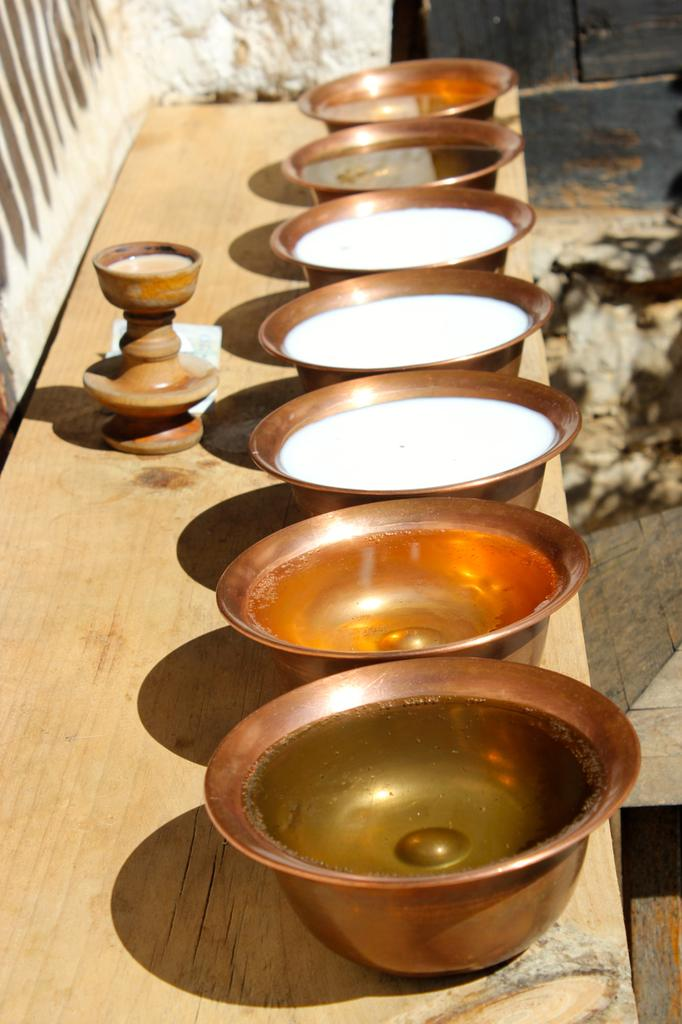What objects are present in the image? There are bowls in the image. What is inside the bowls? The bowls contain milk and oil. What can be seen in the background of the image? There is a wall in the background of the image. What type of reward is being given to the bikes in the image? There are no bikes present in the image, so there is no reward being given to them. 